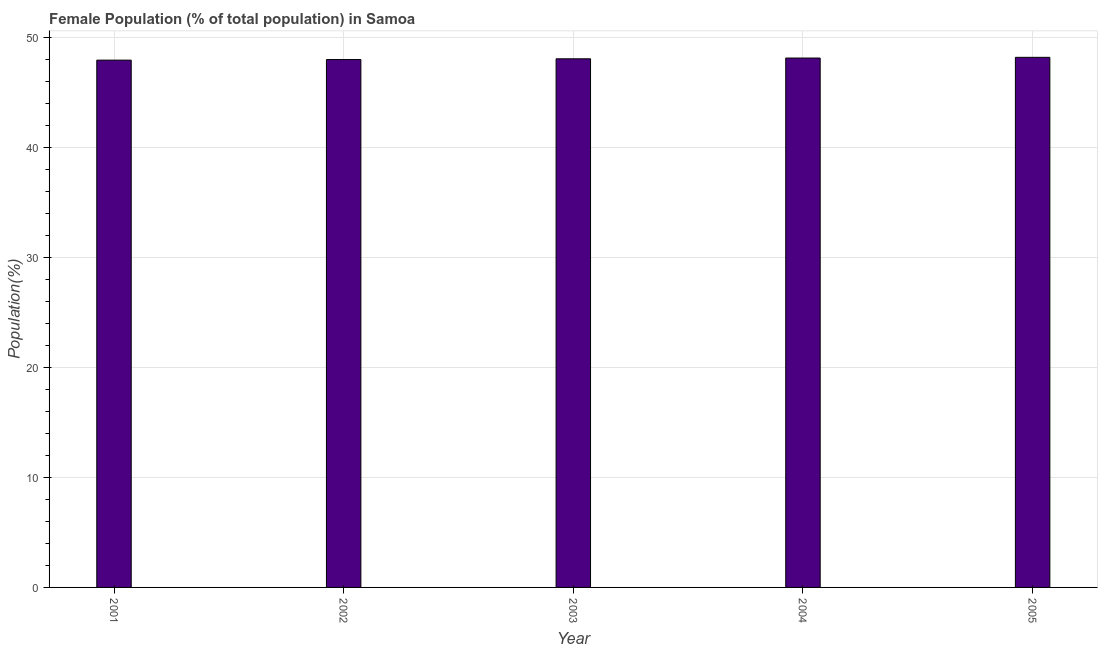What is the title of the graph?
Provide a short and direct response. Female Population (% of total population) in Samoa. What is the label or title of the Y-axis?
Make the answer very short. Population(%). What is the female population in 2002?
Provide a short and direct response. 48.01. Across all years, what is the maximum female population?
Your response must be concise. 48.21. Across all years, what is the minimum female population?
Make the answer very short. 47.96. What is the sum of the female population?
Ensure brevity in your answer.  240.4. What is the difference between the female population in 2002 and 2005?
Ensure brevity in your answer.  -0.2. What is the average female population per year?
Offer a very short reply. 48.08. What is the median female population?
Your answer should be compact. 48.08. In how many years, is the female population greater than 34 %?
Your answer should be compact. 5. What is the ratio of the female population in 2001 to that in 2005?
Offer a very short reply. 0.99. Is the female population in 2001 less than that in 2005?
Your answer should be very brief. Yes. What is the difference between the highest and the second highest female population?
Keep it short and to the point. 0.06. Is the sum of the female population in 2003 and 2005 greater than the maximum female population across all years?
Offer a very short reply. Yes. In how many years, is the female population greater than the average female population taken over all years?
Your response must be concise. 2. Are all the bars in the graph horizontal?
Provide a short and direct response. No. What is the Population(%) in 2001?
Your answer should be compact. 47.96. What is the Population(%) in 2002?
Give a very brief answer. 48.01. What is the Population(%) in 2003?
Keep it short and to the point. 48.08. What is the Population(%) of 2004?
Make the answer very short. 48.15. What is the Population(%) in 2005?
Make the answer very short. 48.21. What is the difference between the Population(%) in 2001 and 2002?
Ensure brevity in your answer.  -0.05. What is the difference between the Population(%) in 2001 and 2003?
Offer a very short reply. -0.12. What is the difference between the Population(%) in 2001 and 2004?
Keep it short and to the point. -0.19. What is the difference between the Population(%) in 2001 and 2005?
Make the answer very short. -0.25. What is the difference between the Population(%) in 2002 and 2003?
Your response must be concise. -0.07. What is the difference between the Population(%) in 2002 and 2004?
Keep it short and to the point. -0.14. What is the difference between the Population(%) in 2002 and 2005?
Your answer should be compact. -0.2. What is the difference between the Population(%) in 2003 and 2004?
Give a very brief answer. -0.07. What is the difference between the Population(%) in 2003 and 2005?
Provide a short and direct response. -0.13. What is the difference between the Population(%) in 2004 and 2005?
Keep it short and to the point. -0.06. What is the ratio of the Population(%) in 2001 to that in 2003?
Make the answer very short. 1. What is the ratio of the Population(%) in 2003 to that in 2004?
Provide a short and direct response. 1. What is the ratio of the Population(%) in 2003 to that in 2005?
Offer a very short reply. 1. What is the ratio of the Population(%) in 2004 to that in 2005?
Your response must be concise. 1. 